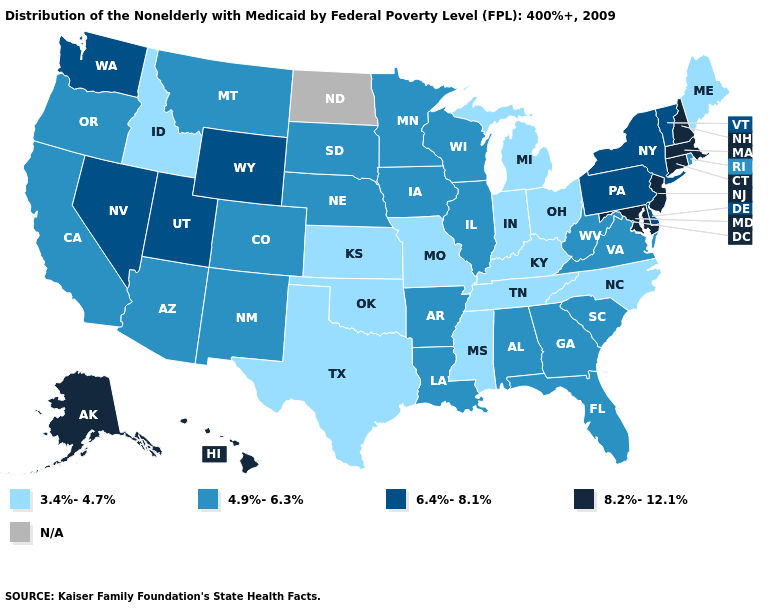What is the value of Oregon?
Write a very short answer. 4.9%-6.3%. Name the states that have a value in the range 8.2%-12.1%?
Be succinct. Alaska, Connecticut, Hawaii, Maryland, Massachusetts, New Hampshire, New Jersey. Name the states that have a value in the range 3.4%-4.7%?
Write a very short answer. Idaho, Indiana, Kansas, Kentucky, Maine, Michigan, Mississippi, Missouri, North Carolina, Ohio, Oklahoma, Tennessee, Texas. Does New Hampshire have the lowest value in the Northeast?
Be succinct. No. Name the states that have a value in the range 6.4%-8.1%?
Concise answer only. Delaware, Nevada, New York, Pennsylvania, Utah, Vermont, Washington, Wyoming. What is the highest value in the USA?
Write a very short answer. 8.2%-12.1%. What is the highest value in the Northeast ?
Be succinct. 8.2%-12.1%. How many symbols are there in the legend?
Write a very short answer. 5. Name the states that have a value in the range 8.2%-12.1%?
Concise answer only. Alaska, Connecticut, Hawaii, Maryland, Massachusetts, New Hampshire, New Jersey. What is the value of Indiana?
Keep it brief. 3.4%-4.7%. What is the highest value in the MidWest ?
Give a very brief answer. 4.9%-6.3%. Among the states that border Kentucky , does Illinois have the lowest value?
Be succinct. No. Is the legend a continuous bar?
Quick response, please. No. What is the value of South Carolina?
Write a very short answer. 4.9%-6.3%. 